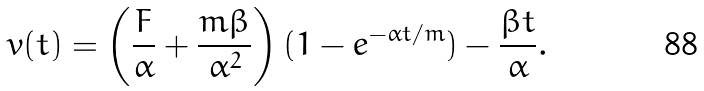Convert formula to latex. <formula><loc_0><loc_0><loc_500><loc_500>v ( t ) = \left ( \frac { F } { \alpha } + \frac { m \beta } { \alpha ^ { 2 } } \right ) ( 1 - e ^ { - \alpha t / m } ) - \frac { \beta t } { \alpha } .</formula> 